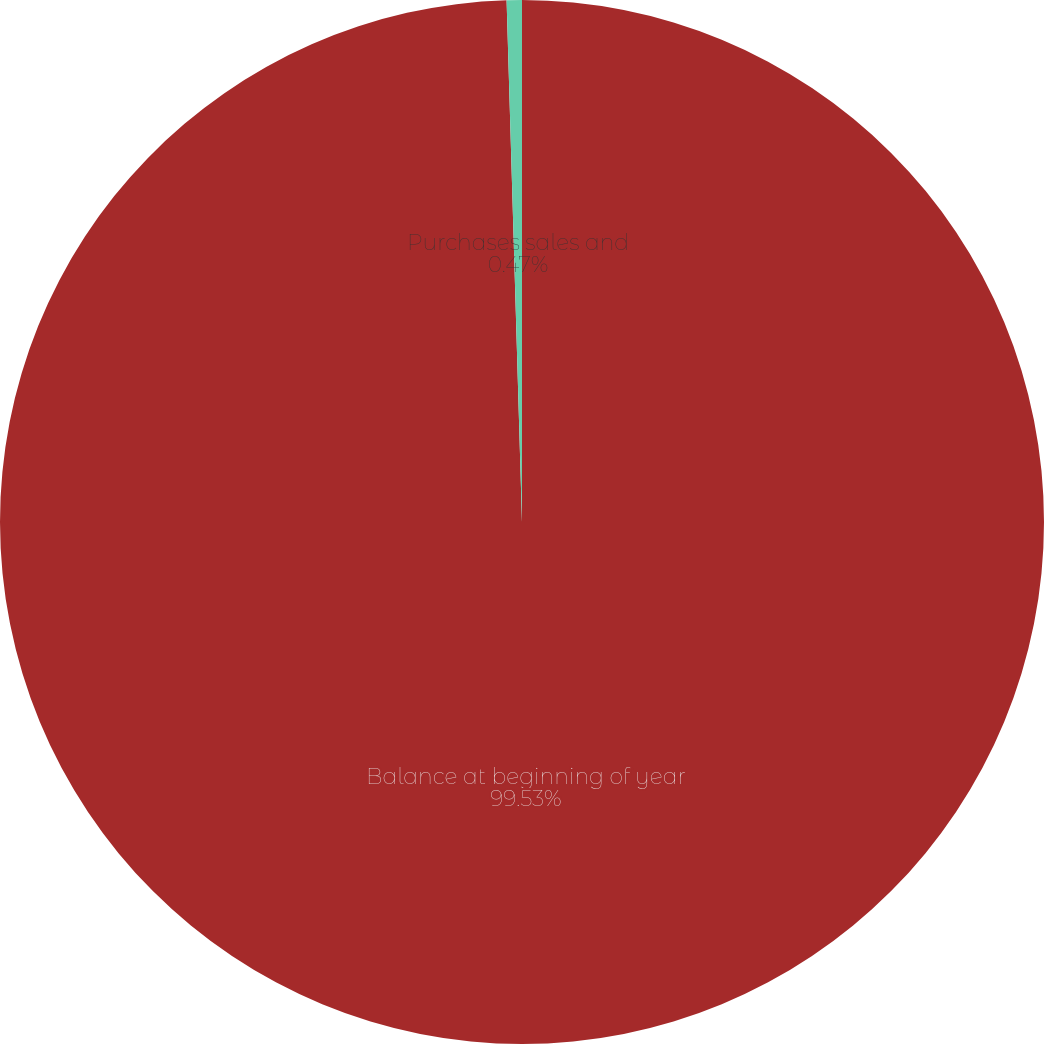<chart> <loc_0><loc_0><loc_500><loc_500><pie_chart><fcel>Balance at beginning of year<fcel>Purchases sales and<nl><fcel>99.53%<fcel>0.47%<nl></chart> 